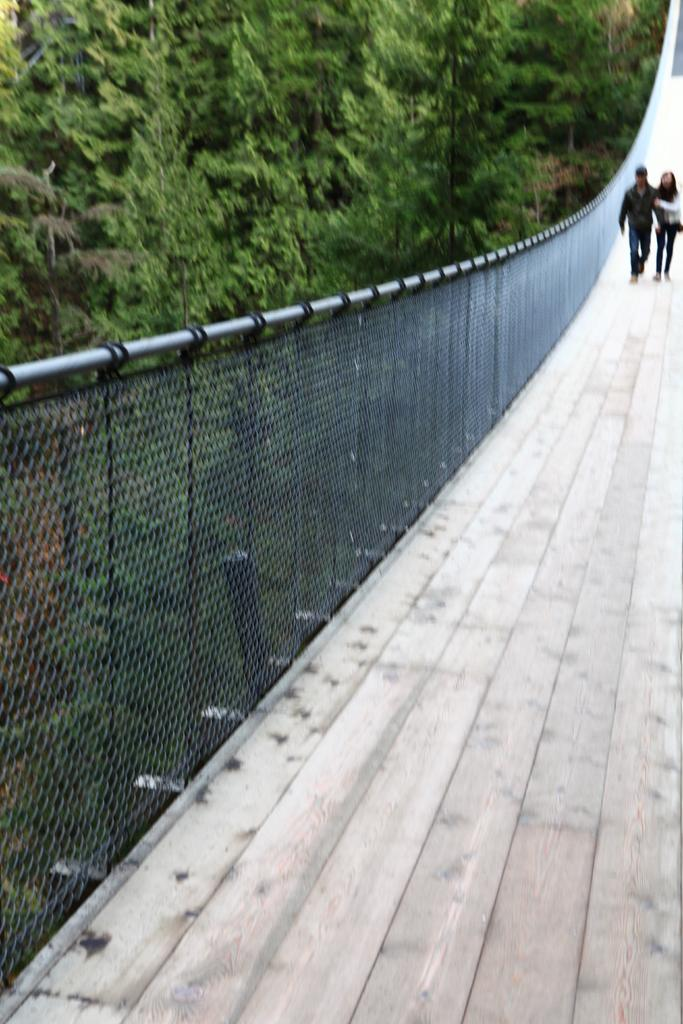What are the two people in the image doing? There is a man and a woman walking on the right side of the image. What type of bridge is visible in the image? There is a rope bridge in the image. What safety feature is present beside the rope bridge? There is a railing beside the rope bridge. What can be seen in the background of the image? There are trees in the background of the image. How much salt is present on the top of the rope bridge in the image? There is no salt present on the top of the rope bridge in the image. 